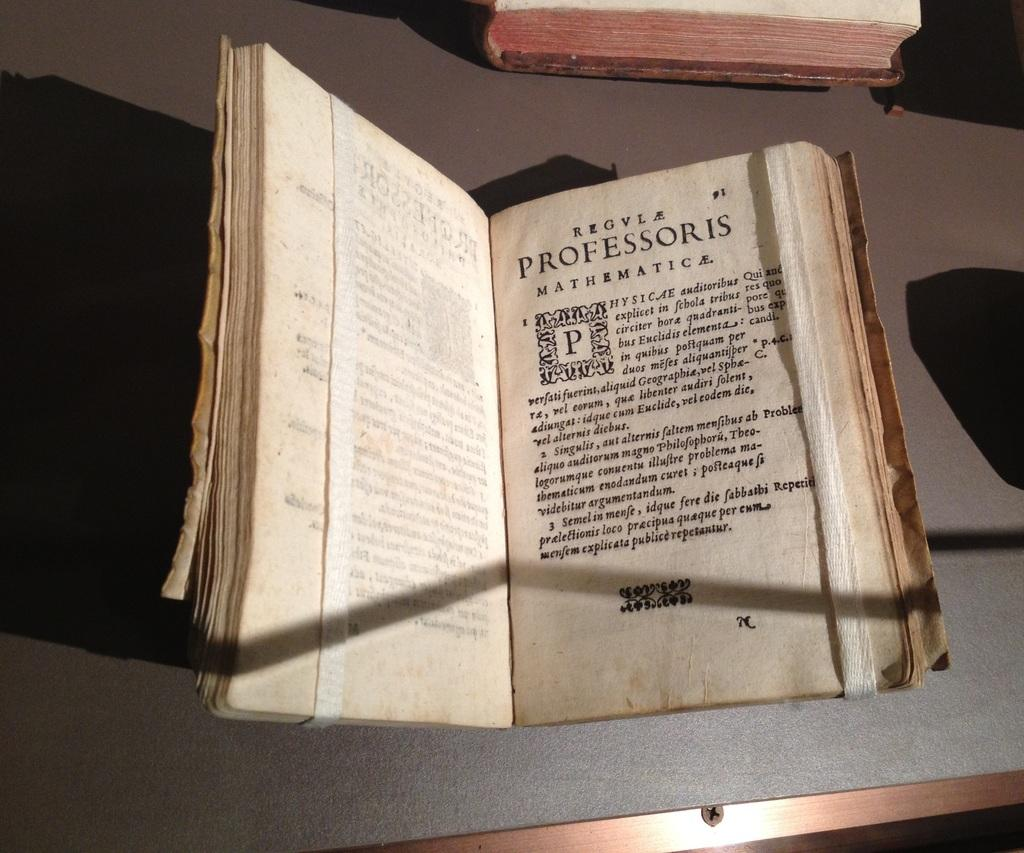<image>
Write a terse but informative summary of the picture. A book written in Latin about mathematics lies open on the table. 